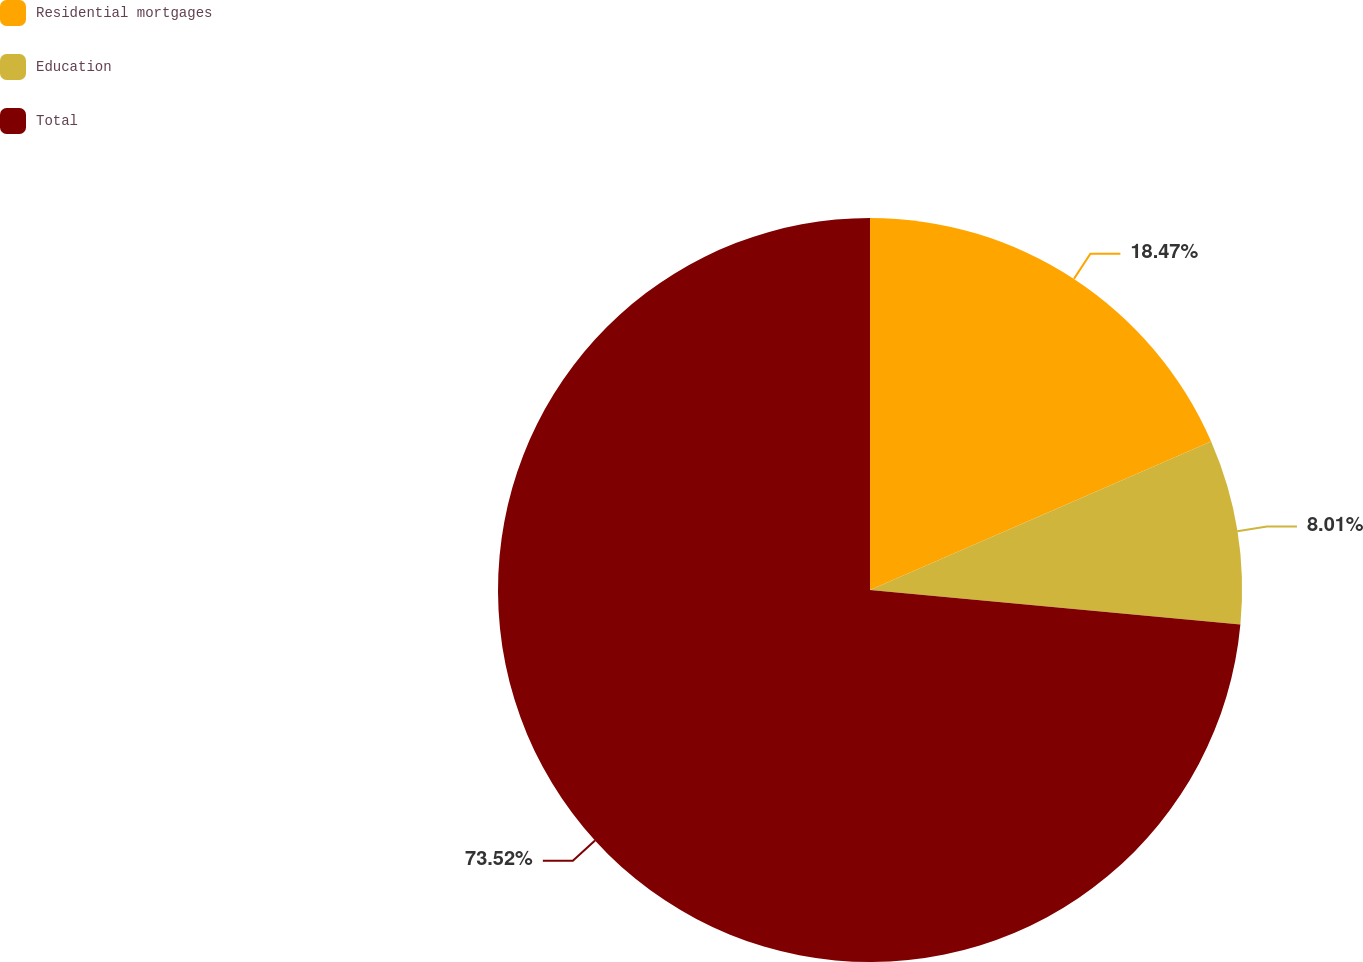<chart> <loc_0><loc_0><loc_500><loc_500><pie_chart><fcel>Residential mortgages<fcel>Education<fcel>Total<nl><fcel>18.47%<fcel>8.01%<fcel>73.52%<nl></chart> 